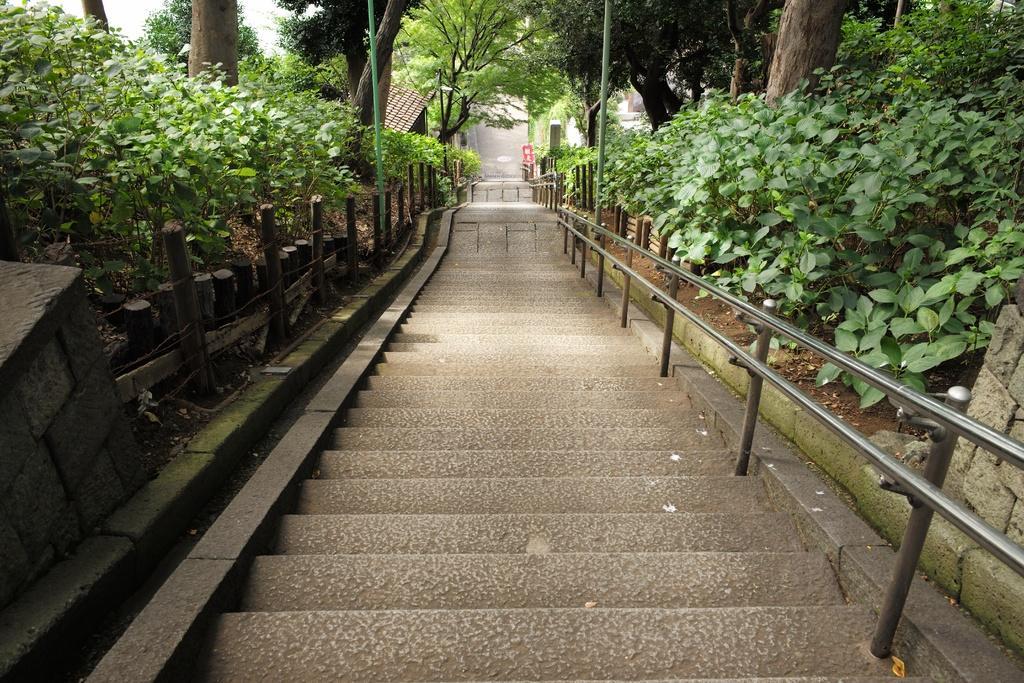Describe this image in one or two sentences. In this picture I can see stairs and few plants and trees and I can see a house. 